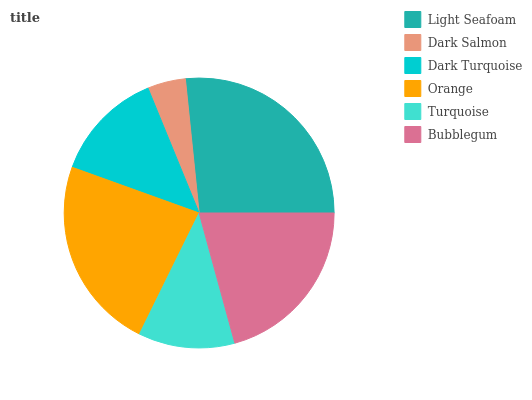Is Dark Salmon the minimum?
Answer yes or no. Yes. Is Light Seafoam the maximum?
Answer yes or no. Yes. Is Dark Turquoise the minimum?
Answer yes or no. No. Is Dark Turquoise the maximum?
Answer yes or no. No. Is Dark Turquoise greater than Dark Salmon?
Answer yes or no. Yes. Is Dark Salmon less than Dark Turquoise?
Answer yes or no. Yes. Is Dark Salmon greater than Dark Turquoise?
Answer yes or no. No. Is Dark Turquoise less than Dark Salmon?
Answer yes or no. No. Is Bubblegum the high median?
Answer yes or no. Yes. Is Dark Turquoise the low median?
Answer yes or no. Yes. Is Dark Salmon the high median?
Answer yes or no. No. Is Light Seafoam the low median?
Answer yes or no. No. 